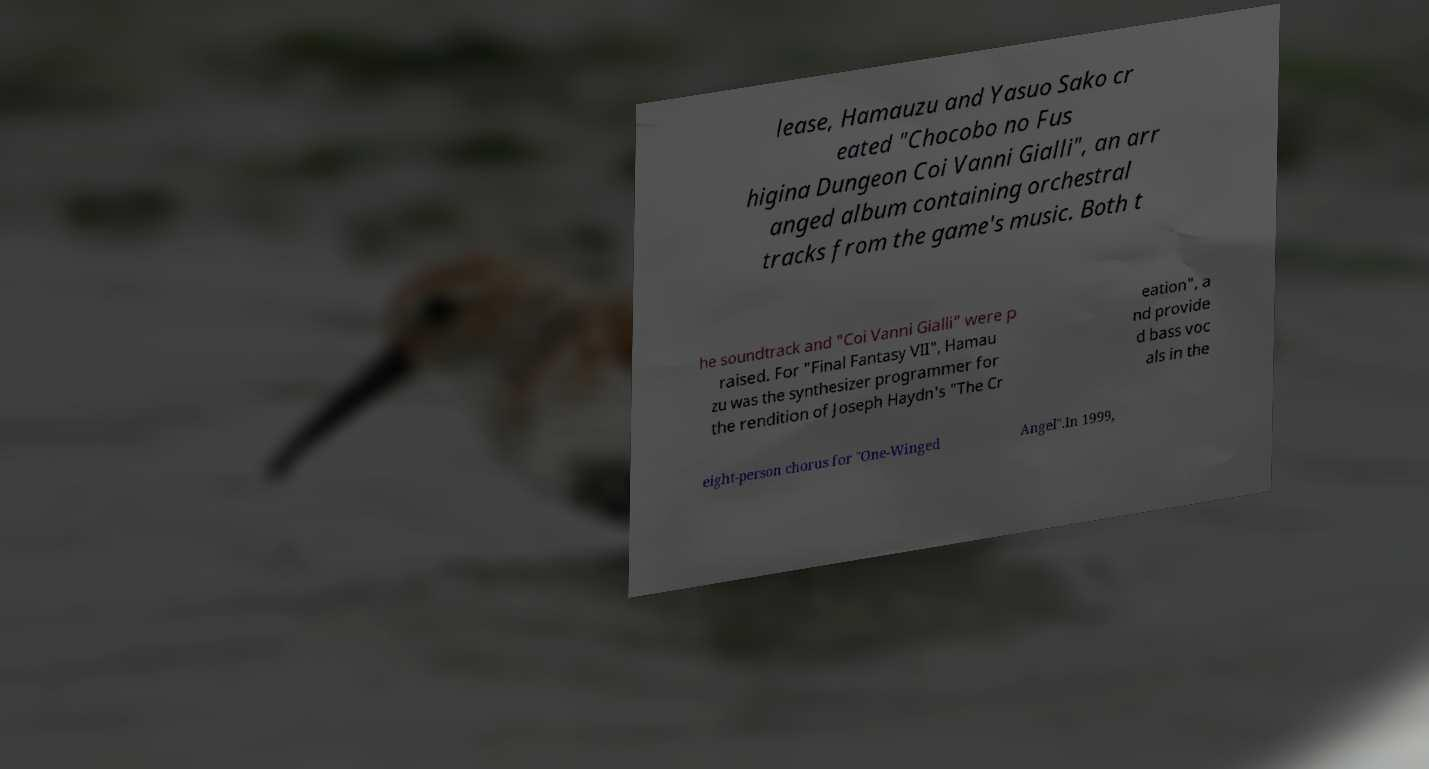Can you accurately transcribe the text from the provided image for me? lease, Hamauzu and Yasuo Sako cr eated "Chocobo no Fus higina Dungeon Coi Vanni Gialli", an arr anged album containing orchestral tracks from the game's music. Both t he soundtrack and "Coi Vanni Gialli" were p raised. For "Final Fantasy VII", Hamau zu was the synthesizer programmer for the rendition of Joseph Haydn's "The Cr eation", a nd provide d bass voc als in the eight-person chorus for "One-Winged Angel".In 1999, 